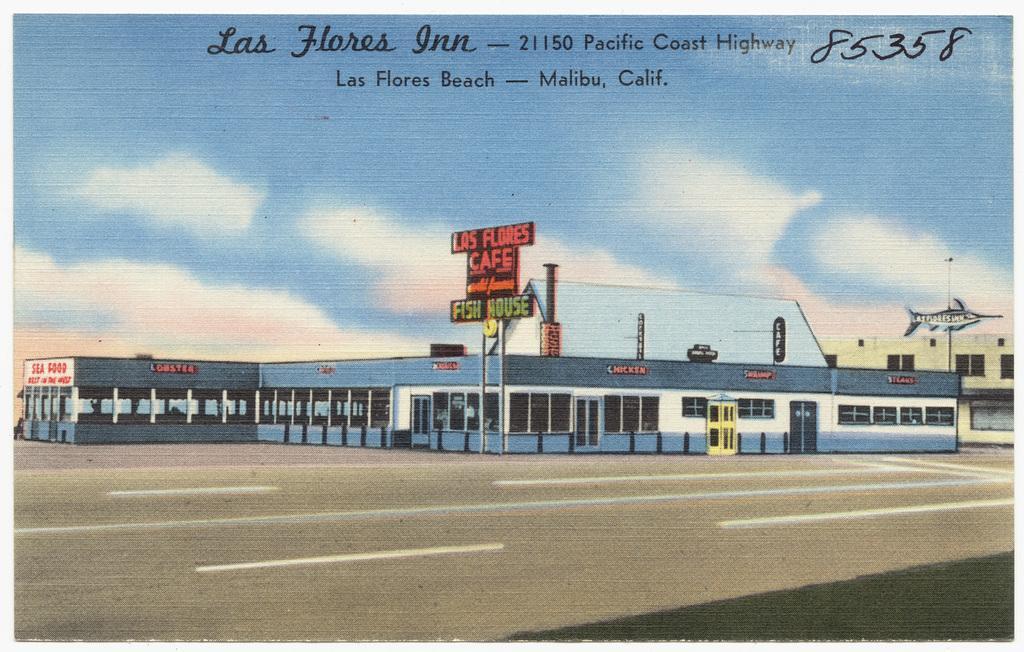How would you summarize this image in a sentence or two? In this image we can see a picture. In the picture there are sky with clouds, advertisement boards, building, road and a chimney. 